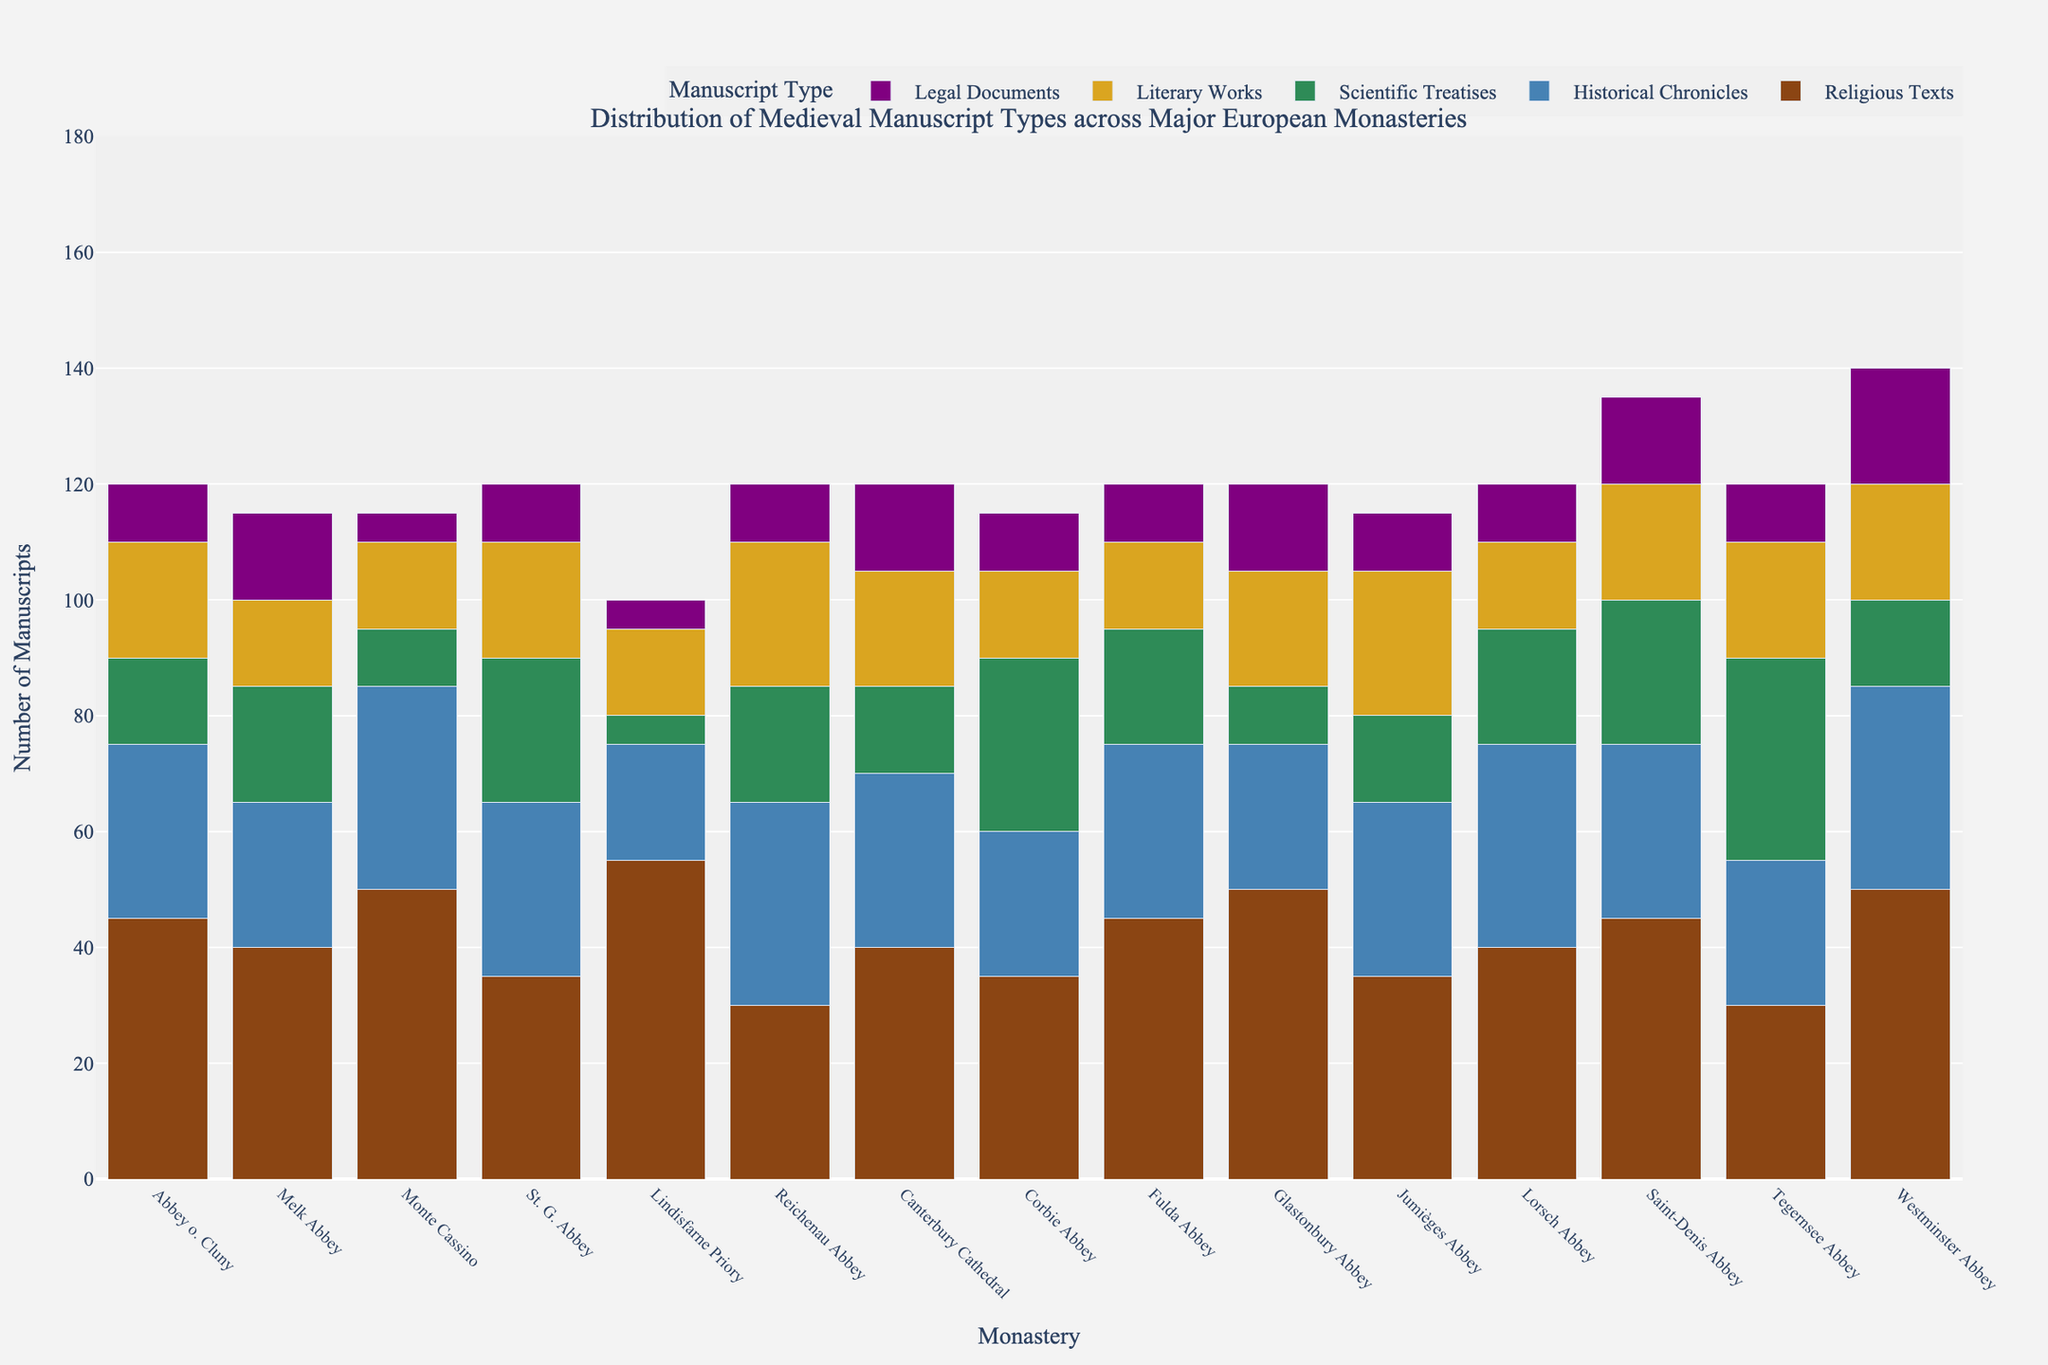What is the total number of religious texts at Monte Cassino and Glastonbury Abbey combined? To find the total number of religious texts at Monte Cassino and Glastonbury Abbey, locate the bar heights for "Religious Texts" at both monasteries. Monte Cassino has 50 and Glastonbury Abbey has 50. Adding these gives 50 + 50 = 100.
Answer: 100 Which monastery has the highest number of scientific treatises? To determine the monastery with the highest number of scientific treatises, compare the heights of the bars representing "Scientific Treatises" for all monasteries. Tegernsee Abbey has the highest bar with 35.
Answer: Tegernsee Abbey Are there more legal documents in Westminster Abbey or St. Gall Abbey? Compare the height of the bars for "Legal Documents" for both Westminster Abbey and St. Gall Abbey. Westminster Abbey has 20, whereas St. Gall Abbey has 10. Therefore, Westminster Abbey has more legal documents.
Answer: Westminster Abbey What is the average number of literary works across all monasteries? To calculate the average number of literary works, sum the counts of "Literary Works" for all monasteries and divide by the number of monasteries. The counts are: 20, 15, 15, 20, 15, 25, 20, 15, 15, 20, 25, 15, 20, 20, 20, summing up to 280. There are 15 monasteries, so the average is 280 / 15 = 18.67.
Answer: 18.67 Which monastery has the least historical chronicles and how many are there? Locate the bars for "Historical Chronicles" and find the shortest one. Lindisfarne Priory has the least with a count of 20.
Answer: Lindisfarne Priory, 20 How many total manuscripts are there in Canterbury Cathedral? Sum the counts for all manuscript types at Canterbury Cathedral: 40 (Religious Texts) + 30 (Historical Chronicles) + 15 (Scientific Treatises) + 20 (Literary Works) + 15 (Legal Documents) = 120.
Answer: 120 Between Abbey of Cluny, Melk Abbey, and Monte Cassino, which one has the highest combined total of religious texts and historical chronicles? Calculate the sum for "Religious Texts" and "Historical Chronicles" for each of these monasteries: Abbey of Cluny: 45 + 30 = 75; Melk Abbey: 40 + 25 = 65; Monte Cassino: 50 + 35 = 85. Monte Cassino has the highest combined total.
Answer: Monte Cassino Which manuscript type has the most consistent (least variation) count across all monasteries? To determine the most consistent manuscript type, compare the bar heights visually across all monasteries, noting which type has the least variance in height. "Religious Texts" appear to be the most consistent across various monasteries.
Answer: Religious Texts How does the count of scientific treatises at Reichenau Abbey compare to that at Fulda Abbey? Compare the "Scientific Treatises" bars for Reichenau Abbey and Fulda Abbey. Reichenau Abbey has 20 and Fulda Abbey also has 20. Both are equal.
Answer: They are equal 